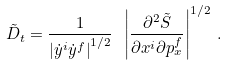<formula> <loc_0><loc_0><loc_500><loc_500>\tilde { D } _ { t } = \frac { 1 } { \left | \dot { y } ^ { i } \dot { y } ^ { f } \right | ^ { 1 / 2 } } \ \left | \frac { \partial ^ { 2 } \tilde { S } } { \partial x ^ { i } \partial p _ { x } ^ { f } } \right | ^ { 1 / 2 } \, .</formula> 